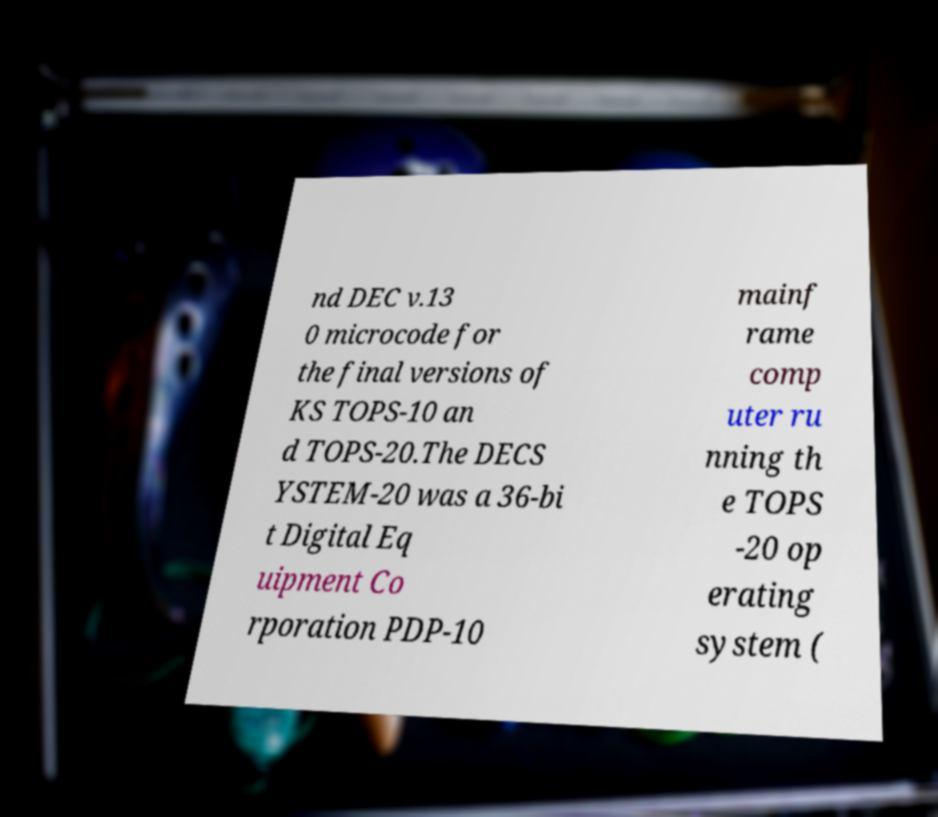Please read and relay the text visible in this image. What does it say? nd DEC v.13 0 microcode for the final versions of KS TOPS-10 an d TOPS-20.The DECS YSTEM-20 was a 36-bi t Digital Eq uipment Co rporation PDP-10 mainf rame comp uter ru nning th e TOPS -20 op erating system ( 